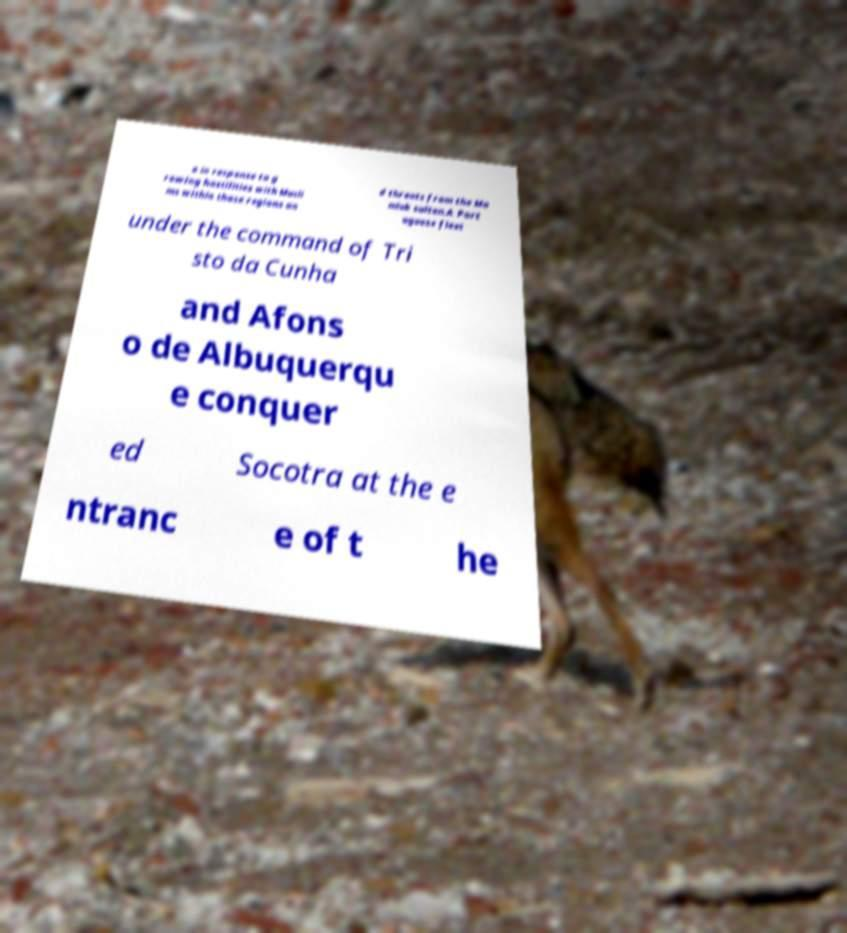Can you accurately transcribe the text from the provided image for me? a in response to g rowing hostilities with Musli ms within those regions an d threats from the Ma mluk sultan.A Port uguese fleet under the command of Tri sto da Cunha and Afons o de Albuquerqu e conquer ed Socotra at the e ntranc e of t he 